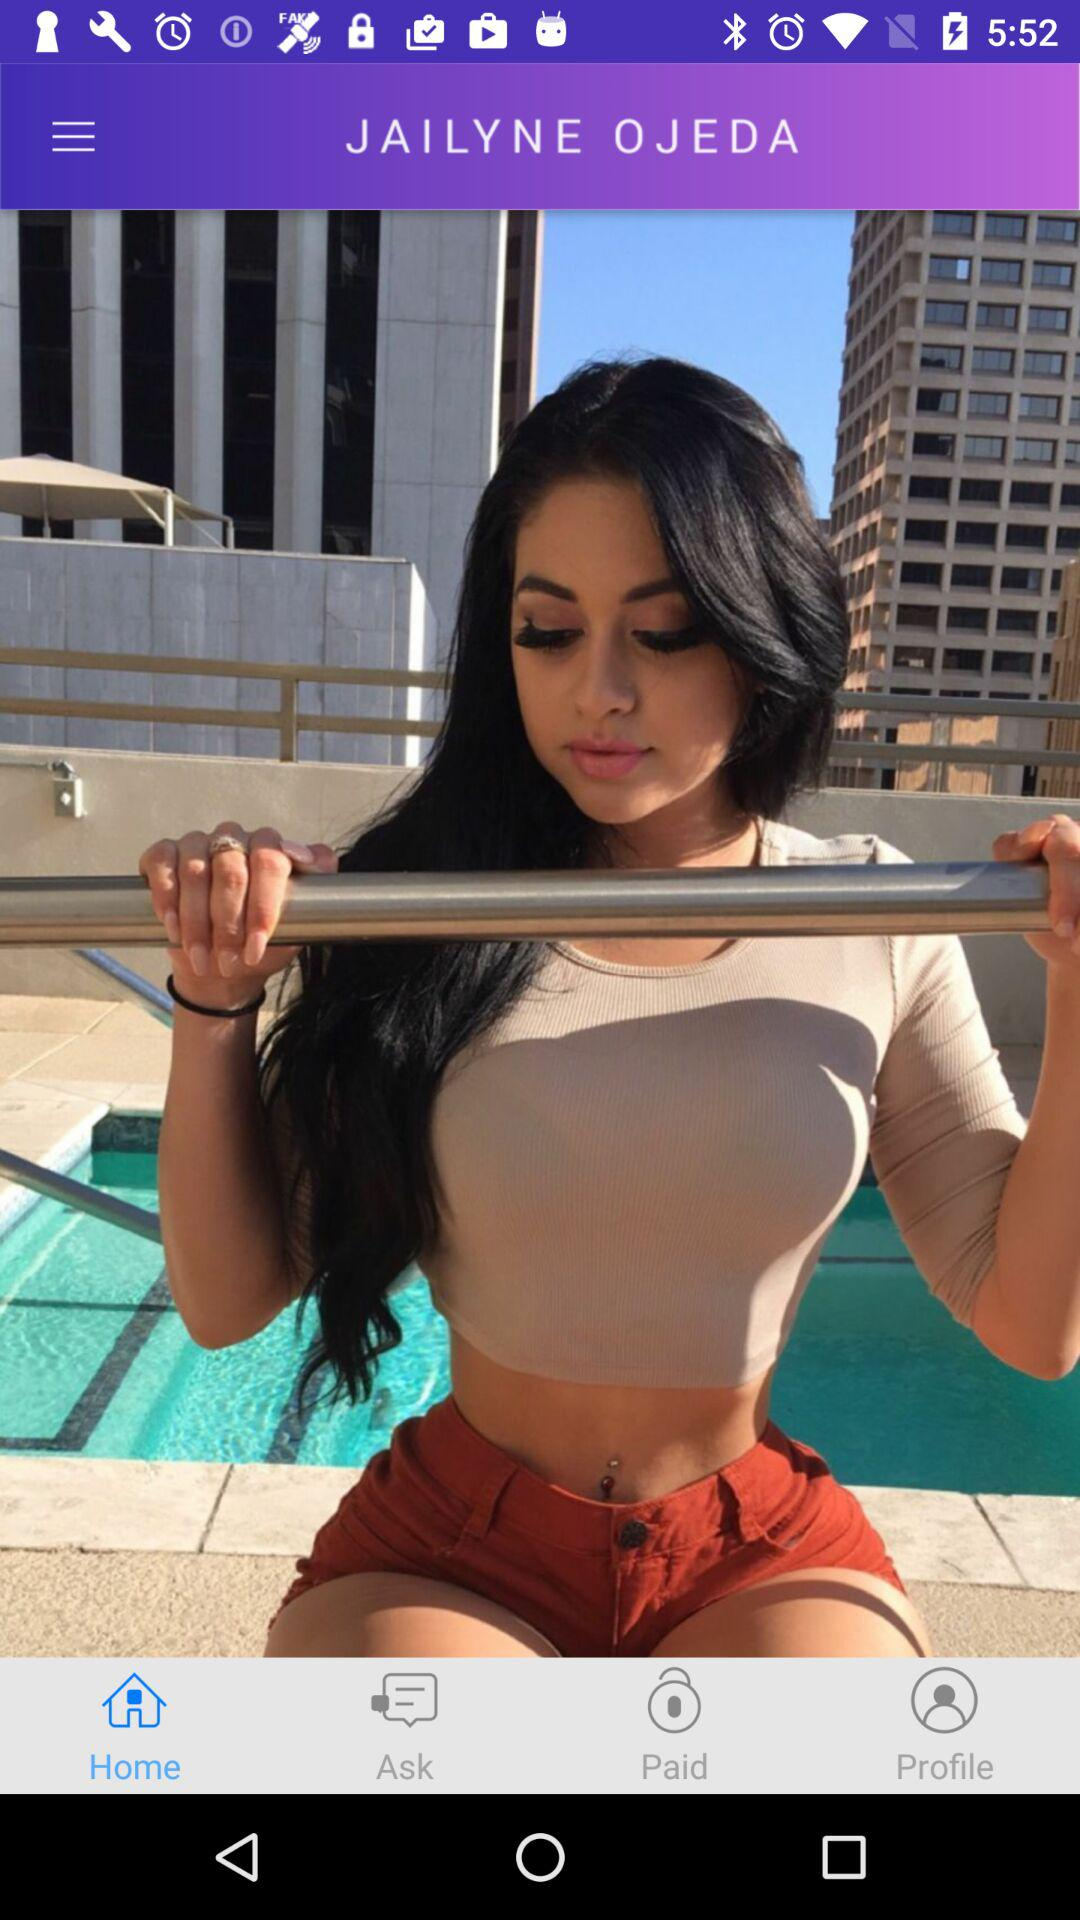Which tab is selected? The selected tab is "Home". 